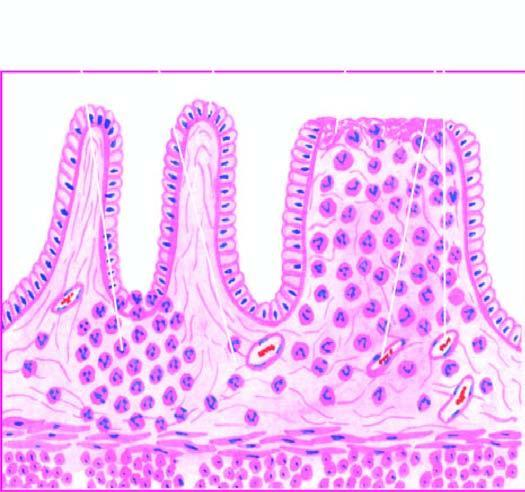re the histological features present superficial ulcerations, with mucosal infiltration by inflammatory cells and a 'crypt abscess '?
Answer the question using a single word or phrase. No 